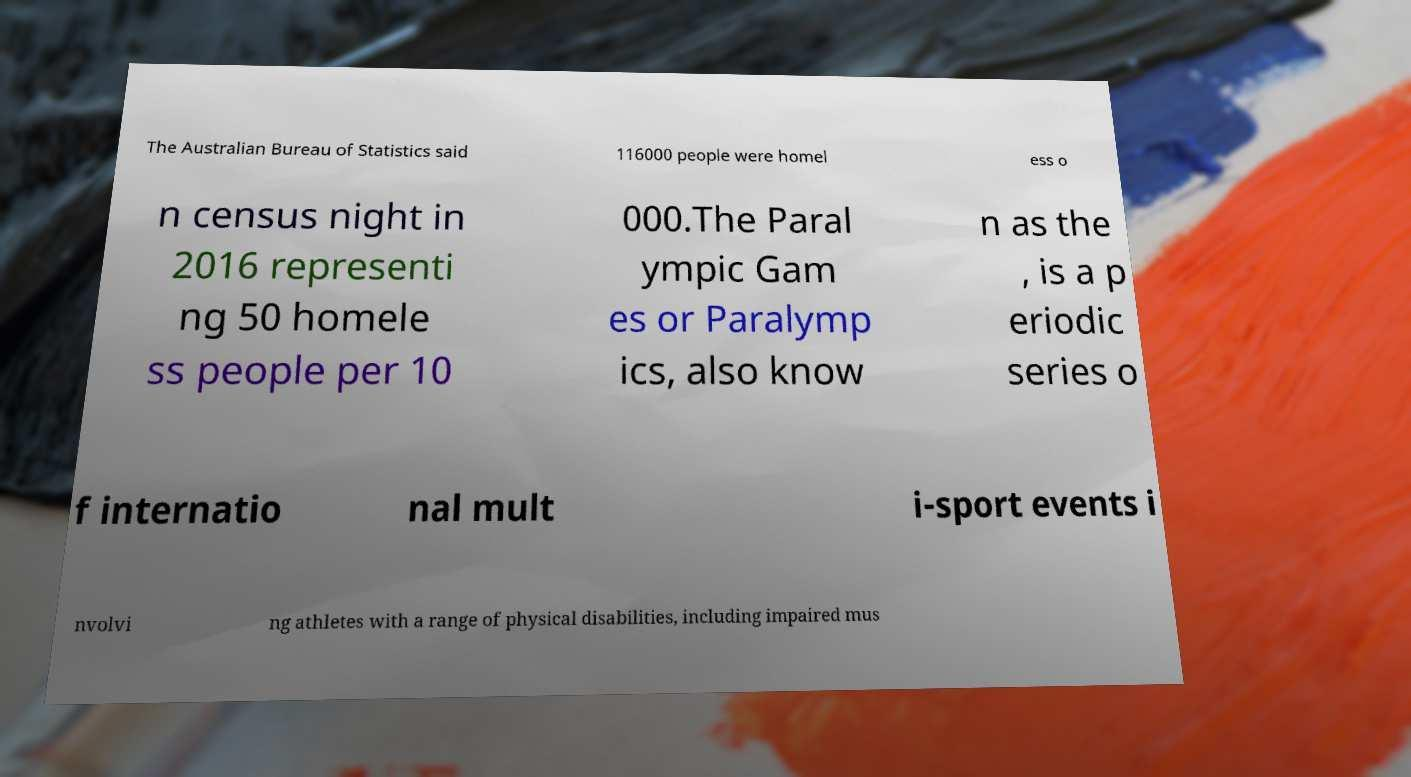Can you read and provide the text displayed in the image?This photo seems to have some interesting text. Can you extract and type it out for me? The Australian Bureau of Statistics said 116000 people were homel ess o n census night in 2016 representi ng 50 homele ss people per 10 000.The Paral ympic Gam es or Paralymp ics, also know n as the , is a p eriodic series o f internatio nal mult i-sport events i nvolvi ng athletes with a range of physical disabilities, including impaired mus 